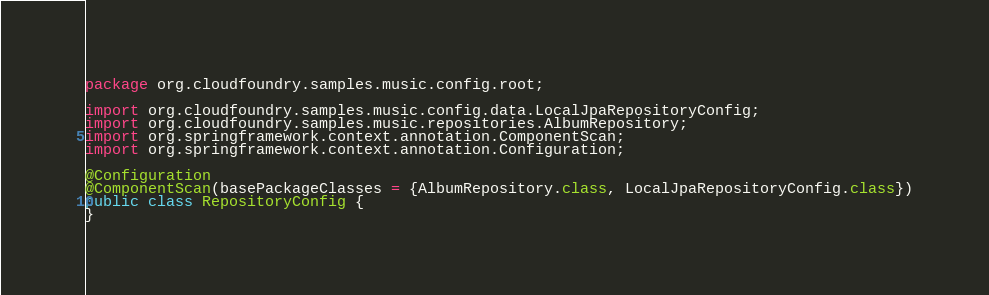Convert code to text. <code><loc_0><loc_0><loc_500><loc_500><_Java_>package org.cloudfoundry.samples.music.config.root;

import org.cloudfoundry.samples.music.config.data.LocalJpaRepositoryConfig;
import org.cloudfoundry.samples.music.repositories.AlbumRepository;
import org.springframework.context.annotation.ComponentScan;
import org.springframework.context.annotation.Configuration;

@Configuration
@ComponentScan(basePackageClasses = {AlbumRepository.class, LocalJpaRepositoryConfig.class})
public class RepositoryConfig {
}

</code> 